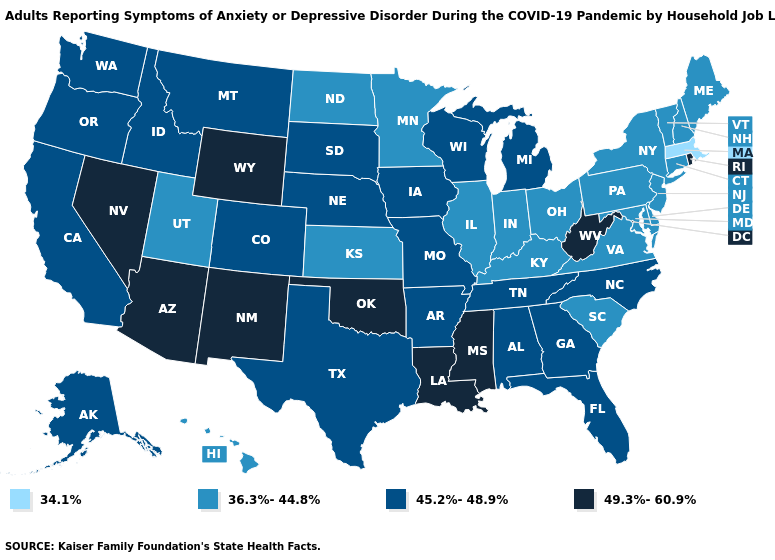Name the states that have a value in the range 45.2%-48.9%?
Be succinct. Alabama, Alaska, Arkansas, California, Colorado, Florida, Georgia, Idaho, Iowa, Michigan, Missouri, Montana, Nebraska, North Carolina, Oregon, South Dakota, Tennessee, Texas, Washington, Wisconsin. Among the states that border Florida , which have the highest value?
Keep it brief. Alabama, Georgia. What is the highest value in the USA?
Write a very short answer. 49.3%-60.9%. Does Florida have a higher value than North Dakota?
Short answer required. Yes. Does Arkansas have the highest value in the USA?
Be succinct. No. What is the lowest value in states that border Iowa?
Short answer required. 36.3%-44.8%. What is the value of Kansas?
Short answer required. 36.3%-44.8%. Which states have the highest value in the USA?
Answer briefly. Arizona, Louisiana, Mississippi, Nevada, New Mexico, Oklahoma, Rhode Island, West Virginia, Wyoming. Does Louisiana have the highest value in the USA?
Keep it brief. Yes. What is the value of Tennessee?
Keep it brief. 45.2%-48.9%. What is the highest value in the USA?
Be succinct. 49.3%-60.9%. Name the states that have a value in the range 34.1%?
Short answer required. Massachusetts. Which states have the lowest value in the Northeast?
Short answer required. Massachusetts. Name the states that have a value in the range 49.3%-60.9%?
Be succinct. Arizona, Louisiana, Mississippi, Nevada, New Mexico, Oklahoma, Rhode Island, West Virginia, Wyoming. 